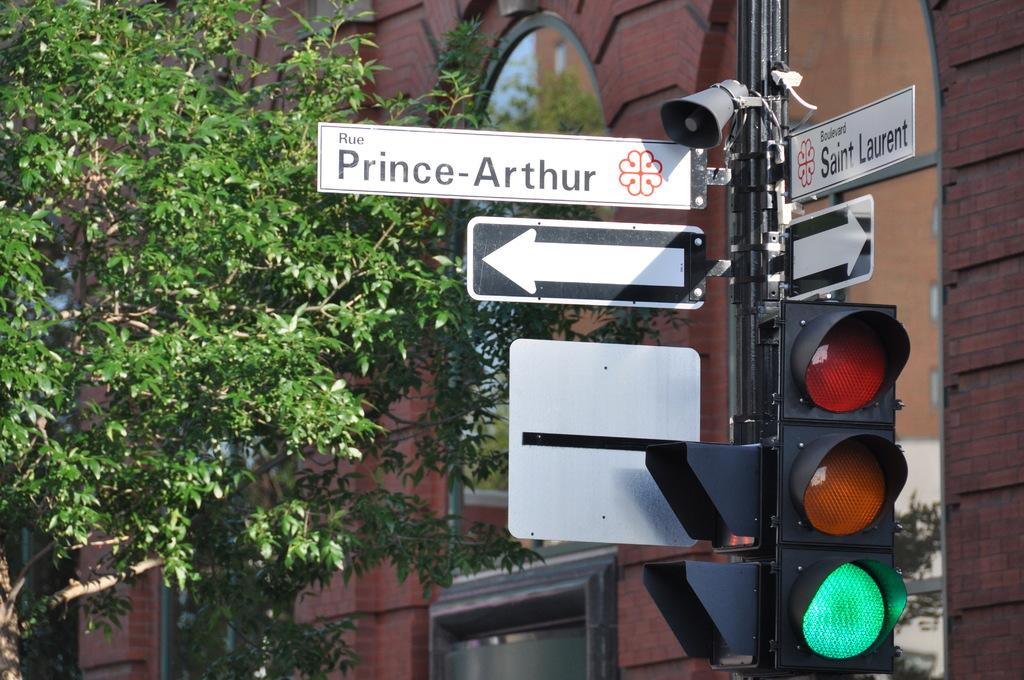Provide a one-sentence caption for the provided image. A street sign for Rue Prince-Arthur is just above an arrow pointing to the left. 